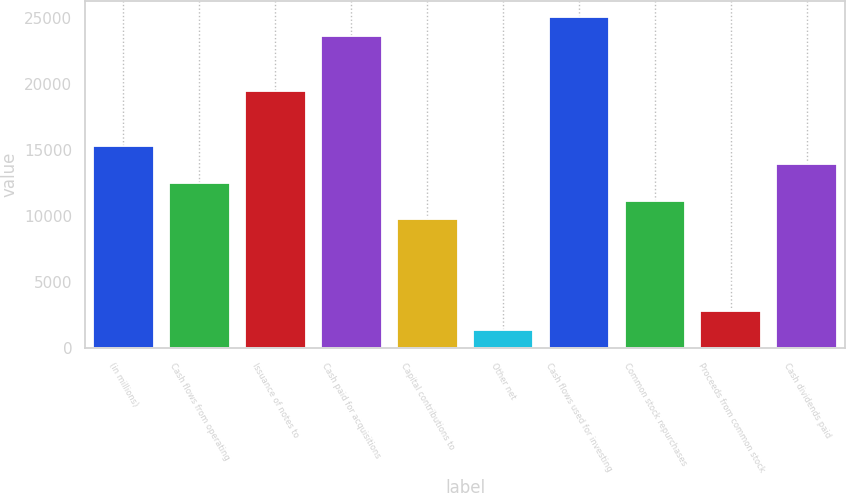Convert chart. <chart><loc_0><loc_0><loc_500><loc_500><bar_chart><fcel>(in millions)<fcel>Cash flows from operating<fcel>Issuance of notes to<fcel>Cash paid for acquisitions<fcel>Capital contributions to<fcel>Other net<fcel>Cash flows used for investing<fcel>Common stock repurchases<fcel>Proceeds from common stock<fcel>Cash dividends paid<nl><fcel>15317.9<fcel>12538.1<fcel>19487.6<fcel>23657.3<fcel>9758.3<fcel>1418.9<fcel>25047.2<fcel>11148.2<fcel>2808.8<fcel>13928<nl></chart> 